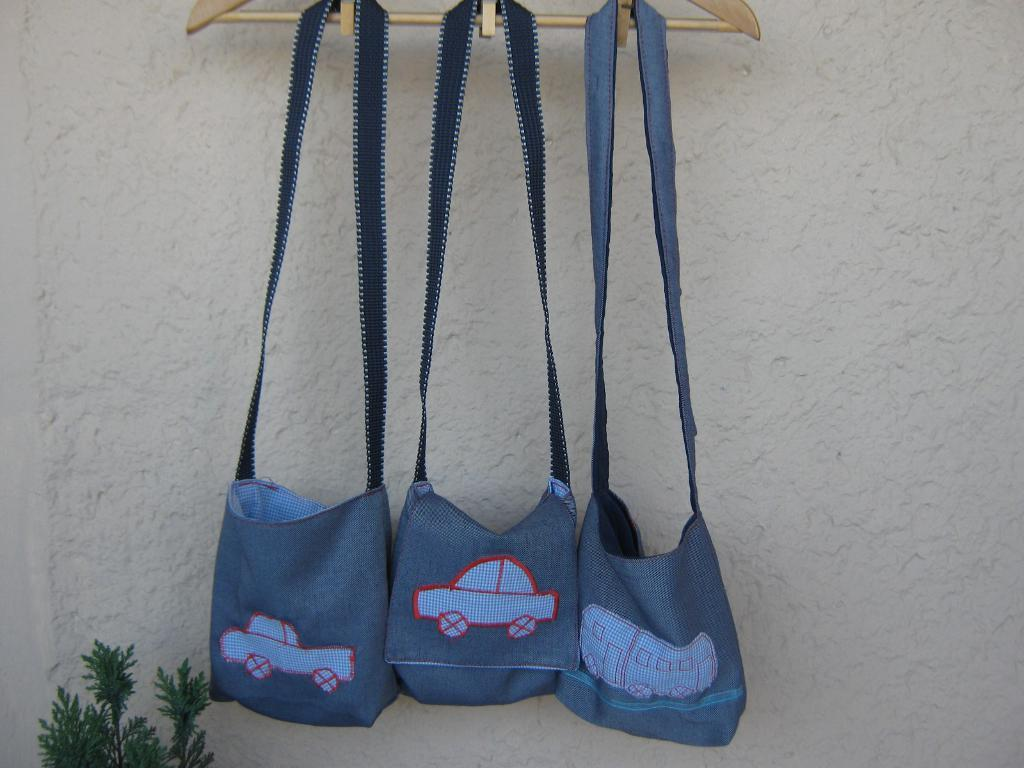What objects are hanging on the hanger in the image? There are two bags hanging on a hanger in the image. Can you describe the plant in the image? There is a plant in the left side corner of the image. What type of cheese is being served at the birthday party in the image? There is no birthday party or cheese present in the image. How many stations are set up for the guests at the station in the image? There is no station present in the image. 